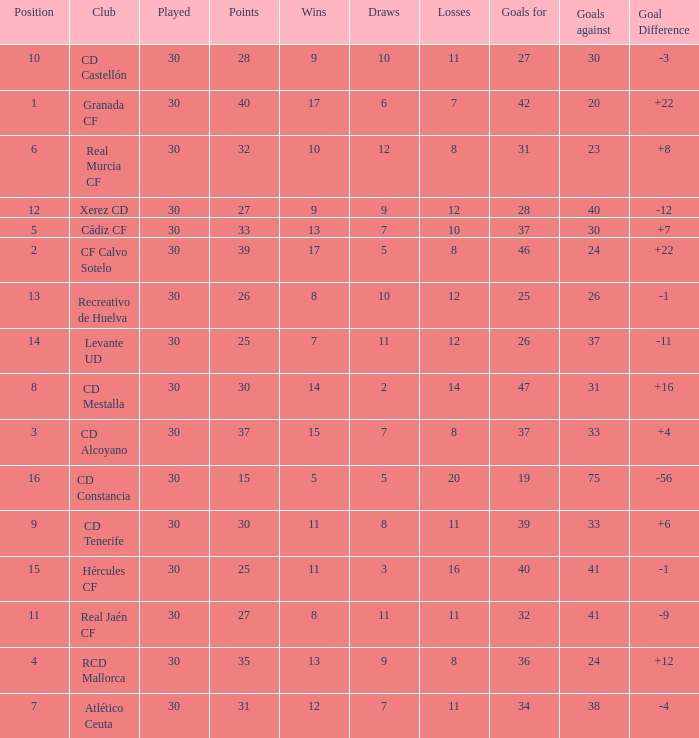How many Draws have 30 Points, and less than 33 Goals against? 1.0. 